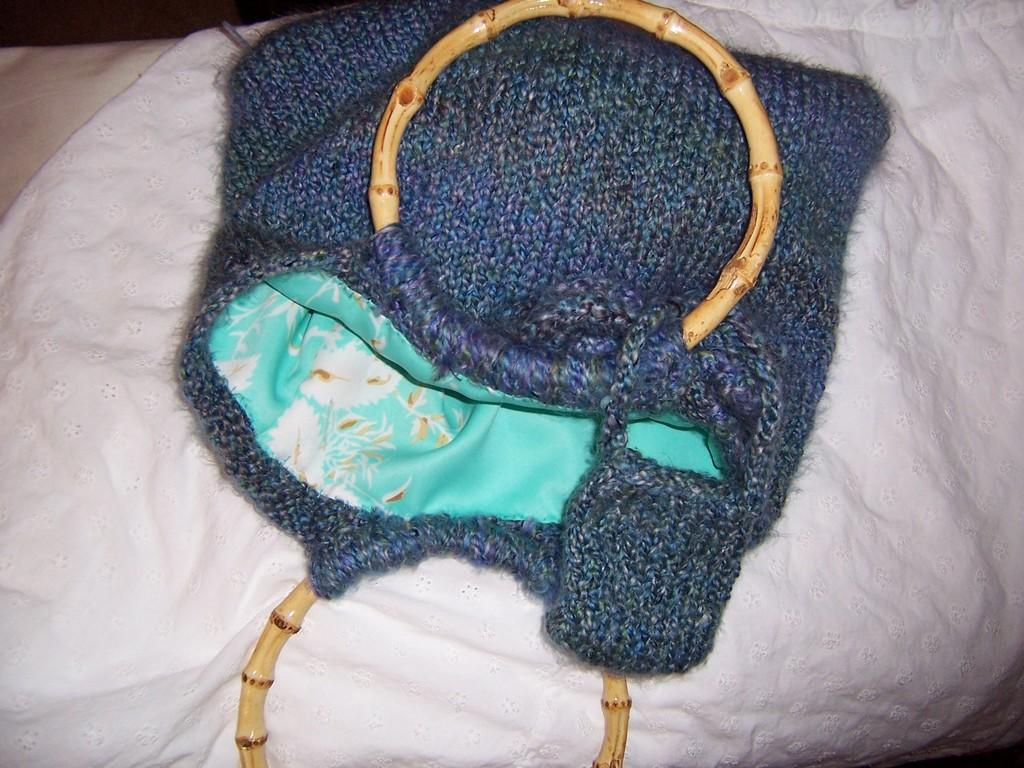What type of bag is present in the image? There is a blue color woolen bag in the image. What is the bag placed on? The woolen bag is placed on a white sheet. What is the wealth status of the cat in the image? There is no cat present in the image, so it is not possible to determine its wealth status. 